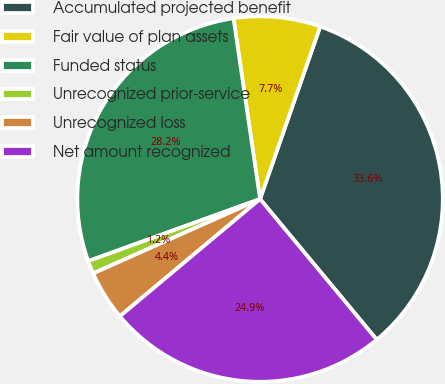Convert chart to OTSL. <chart><loc_0><loc_0><loc_500><loc_500><pie_chart><fcel>Accumulated projected benefit<fcel>Fair value of plan assets<fcel>Funded status<fcel>Unrecognized prior-service<fcel>Unrecognized loss<fcel>Net amount recognized<nl><fcel>33.64%<fcel>7.66%<fcel>28.19%<fcel>1.16%<fcel>4.41%<fcel>24.94%<nl></chart> 